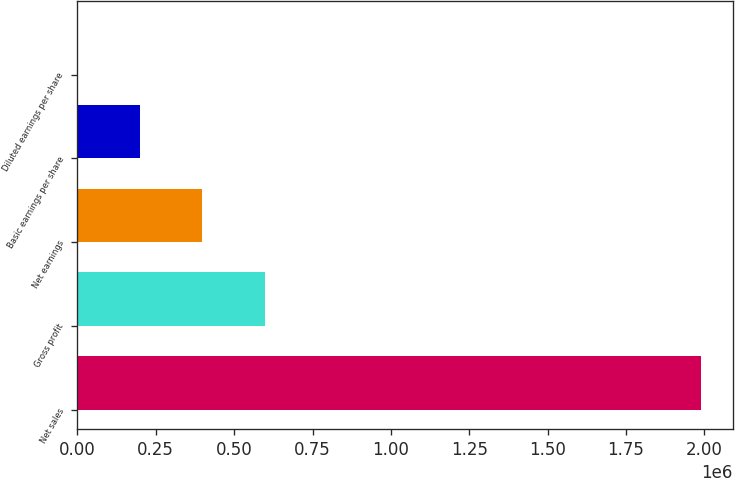<chart> <loc_0><loc_0><loc_500><loc_500><bar_chart><fcel>Net sales<fcel>Gross profit<fcel>Net earnings<fcel>Basic earnings per share<fcel>Diluted earnings per share<nl><fcel>1.99066e+06<fcel>597199<fcel>398133<fcel>199068<fcel>2.06<nl></chart> 